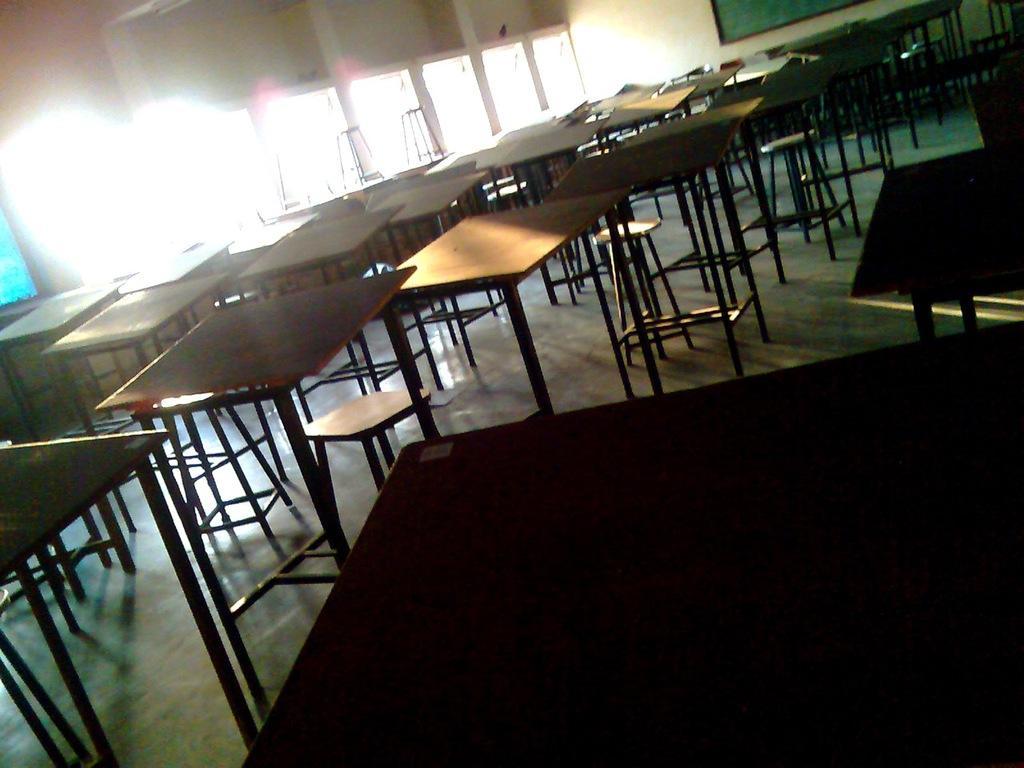Could you give a brief overview of what you see in this image? In this image I can see number of tables, number of stools, windows and over there I can see a green colour board. 